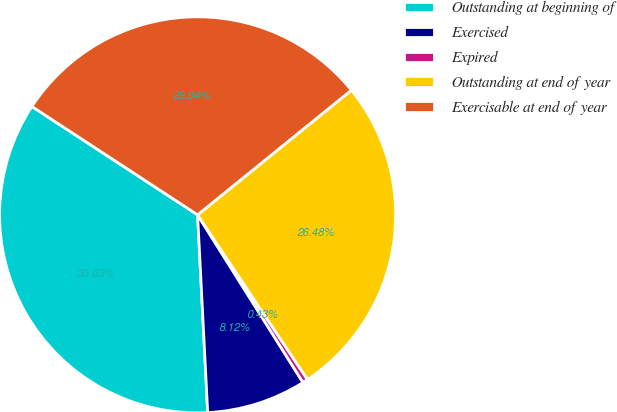Convert chart. <chart><loc_0><loc_0><loc_500><loc_500><pie_chart><fcel>Outstanding at beginning of<fcel>Exercised<fcel>Expired<fcel>Outstanding at end of year<fcel>Exercisable at end of year<nl><fcel>35.03%<fcel>8.12%<fcel>0.43%<fcel>26.48%<fcel>29.94%<nl></chart> 